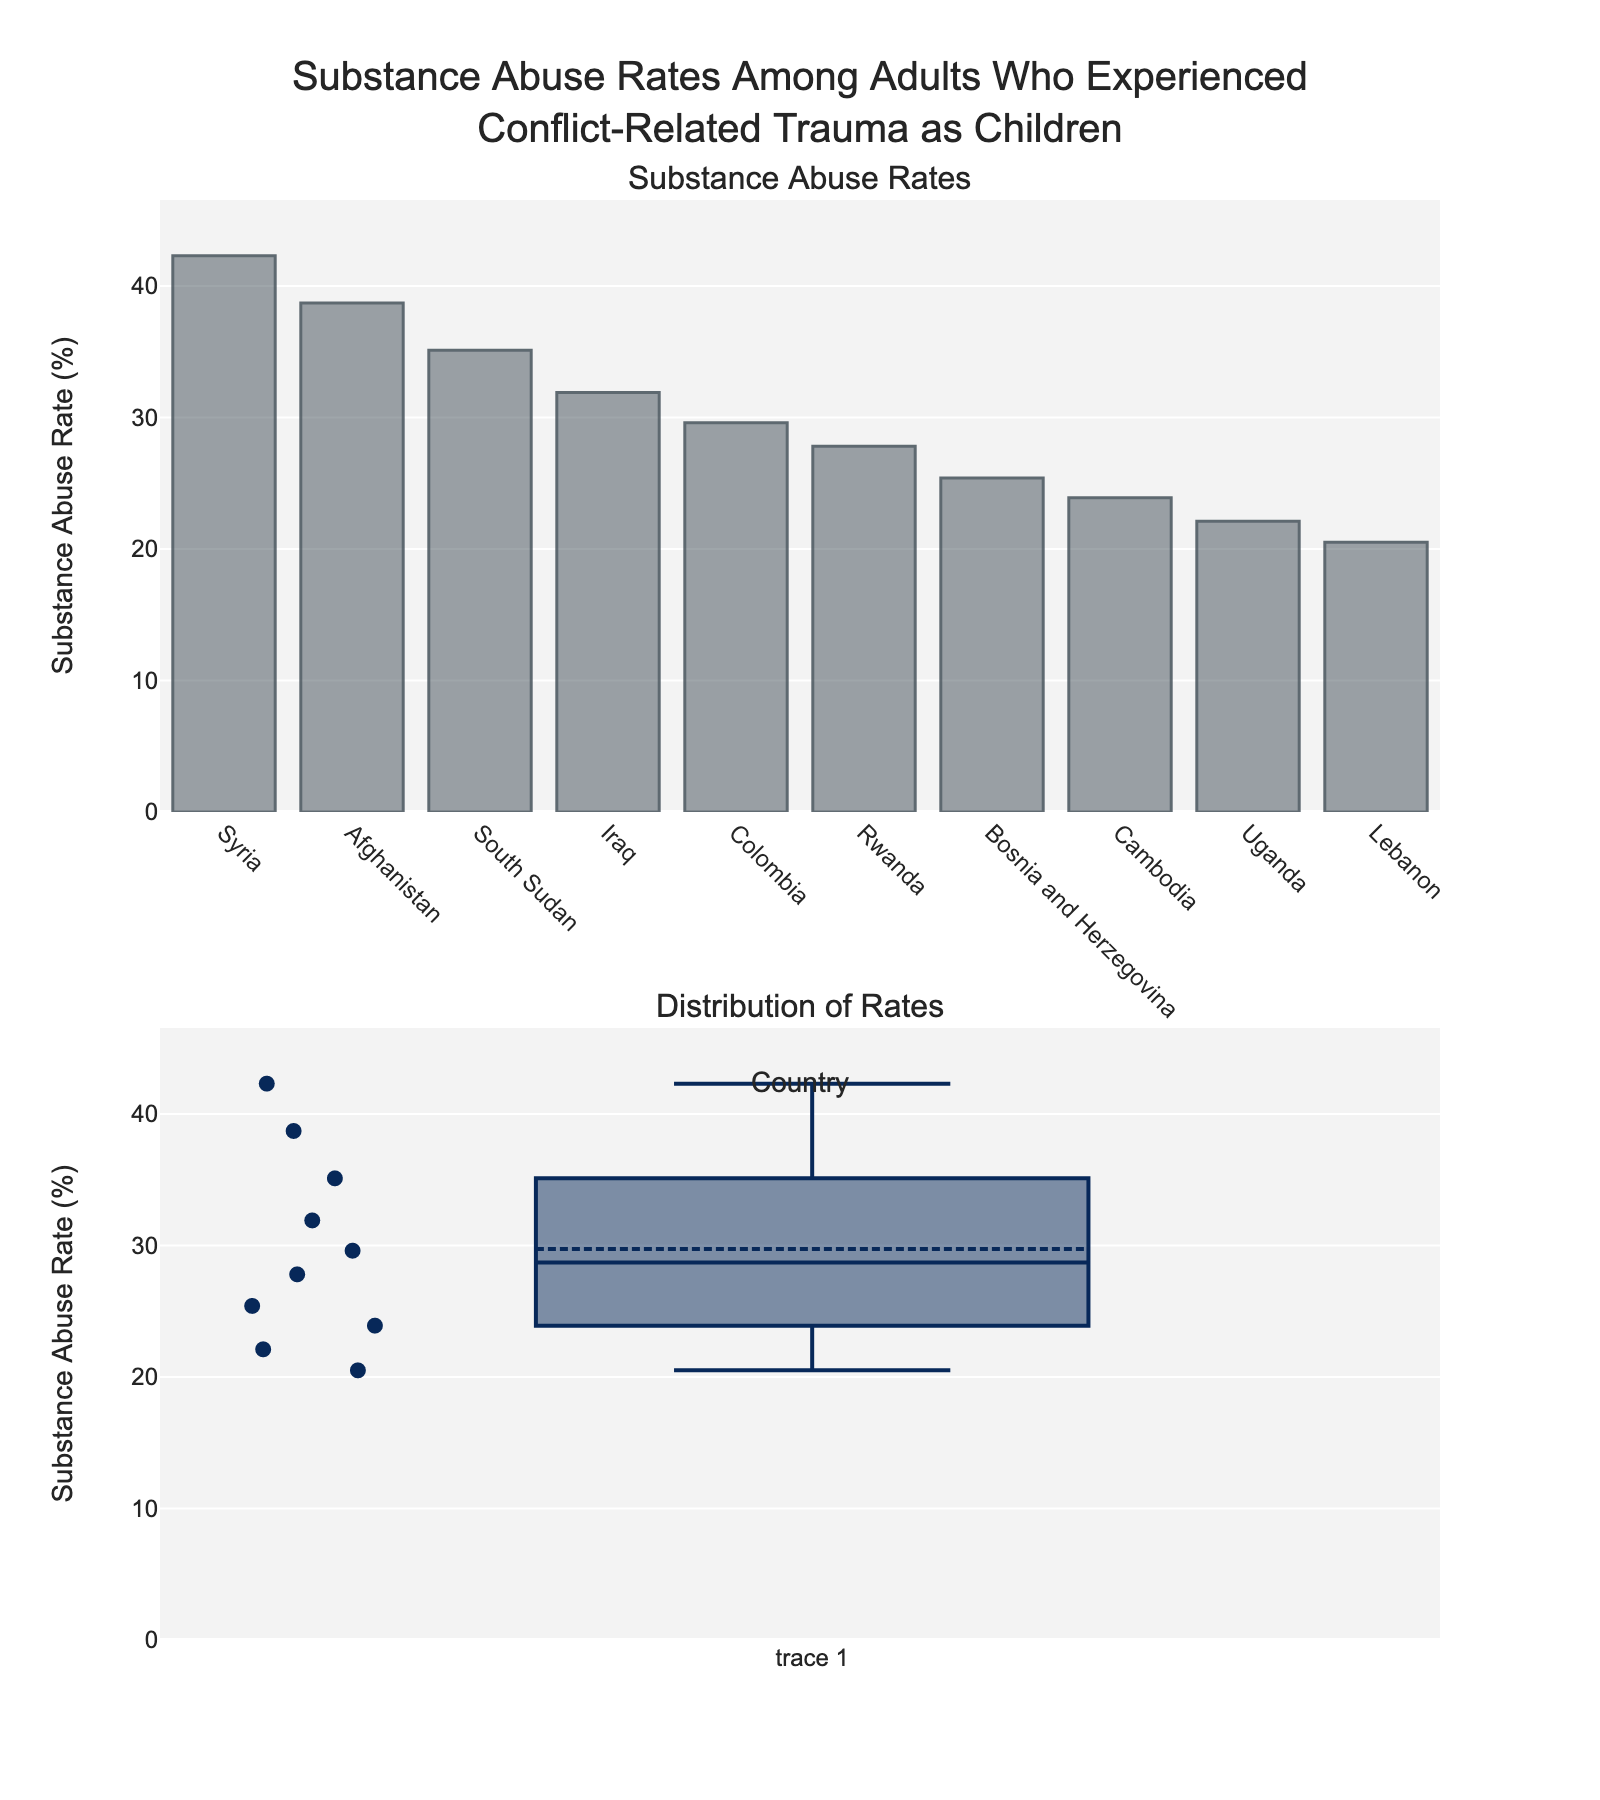What is the country with the highest substance abuse rate? The first subplot is a bar chart where each bar represents a country, and the height of the bar indicates the substance abuse rate. The tallest bar corresponds to Syria.
Answer: Syria How many countries have a substance abuse rate above 30%? In the bar chart, look for bars that extend above the 30% mark. These countries are Syria, Afghanistan, South Sudan, and Iraq.
Answer: 4 Which country has the lowest substance abuse rate? The bar chart shows various countries and their respective substance abuse rates. The shortest bar, which represents the lowest rate, corresponds to Lebanon.
Answer: Lebanon What is the range of substance abuse rates across all countries displayed? To find the range, subtract the lowest rate (Lebanon: 20.5%) from the highest rate (Syria: 42.3%). The range is calculated as 42.3% - 20.5% = 21.8%.
Answer: 21.8% Which country has a substance abuse rate closest to the median value? The median value is visible in the box plot. Use this visualization to see which country's rate is closest to this median point. Bosnia and Herzegovina's rate (25.4%) is near the box plot's median mark.
Answer: Bosnia and Herzegovina What is the interquartile range (IQR) of substance abuse rates? The box plot displays the IQR as the length of the box, which stretches from the first quartile (Q1) to the third quartile (Q3). Using this visualization, estimate the IQR from the plot, noting the percentages at Q1 and Q3. Let's assume Q3 is approximately 36% and Q1 is around 23%, making the IQR = 36% - 23% = 13%.
Answer: 13% Are there any outliers in the substance abuse rates? Outliers are visible in the box plot as points outside the "whiskers." Examine if there are any such points. The box plot in the second subplot does not display any points outside the whiskers, indicating no outliers.
Answer: No What is the average substance abuse rate across all countries? Calculate the sum of all the substance abuse rates and divide it by the number of countries. Sum: 42.3 + 38.7 + 35.1 + 31.9 + 29.6 + 27.8 + 25.4 + 23.9 + 22.1 + 20.5 = 297.3%. Divide by the number of countries (10), so the average rate is 297.3% / 10 = 29.73%.
Answer: 29.73% What proportion of the countries have a substance abuse rate below the average? First, find the average rate (29.73%). Count the number of countries below this rate. Lebanon, Uganda, Cambodia, and Bosnia and Herzegovina are below 29.73%, which is 4 out of 10 countries. The proportion is 4/10 = 0.4 or 40%.
Answer: 40% 